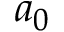Convert formula to latex. <formula><loc_0><loc_0><loc_500><loc_500>a _ { 0 }</formula> 